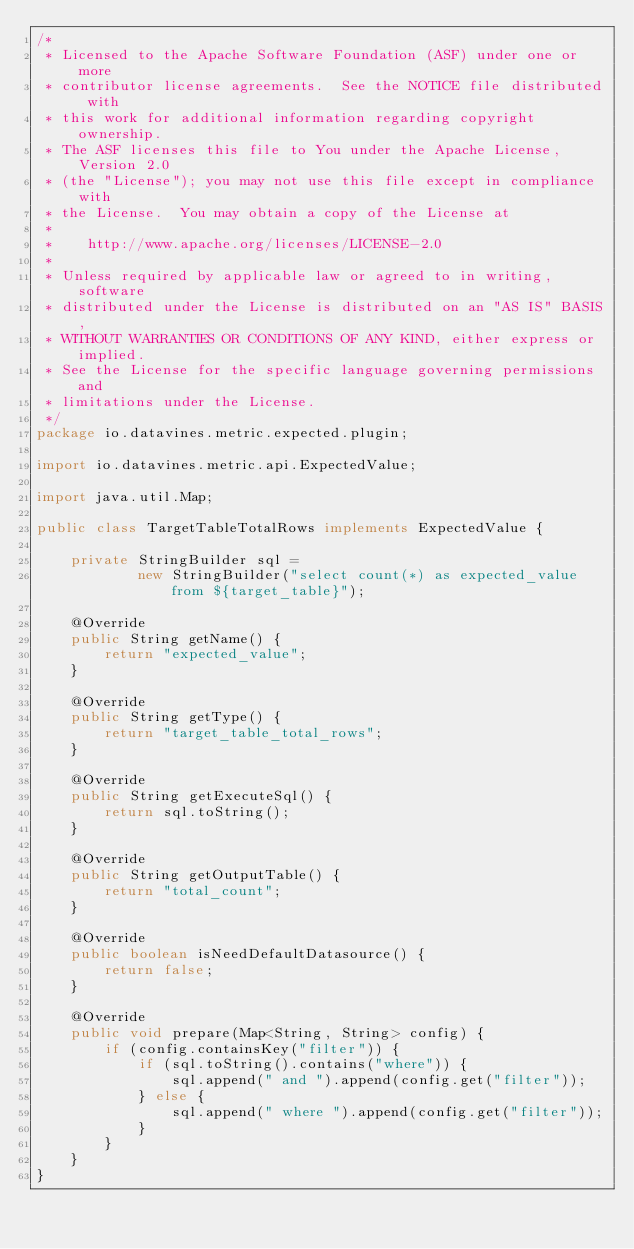Convert code to text. <code><loc_0><loc_0><loc_500><loc_500><_Java_>/*
 * Licensed to the Apache Software Foundation (ASF) under one or more
 * contributor license agreements.  See the NOTICE file distributed with
 * this work for additional information regarding copyright ownership.
 * The ASF licenses this file to You under the Apache License, Version 2.0
 * (the "License"); you may not use this file except in compliance with
 * the License.  You may obtain a copy of the License at
 *
 *    http://www.apache.org/licenses/LICENSE-2.0
 *
 * Unless required by applicable law or agreed to in writing, software
 * distributed under the License is distributed on an "AS IS" BASIS,
 * WITHOUT WARRANTIES OR CONDITIONS OF ANY KIND, either express or implied.
 * See the License for the specific language governing permissions and
 * limitations under the License.
 */
package io.datavines.metric.expected.plugin;

import io.datavines.metric.api.ExpectedValue;

import java.util.Map;

public class TargetTableTotalRows implements ExpectedValue {

    private StringBuilder sql =
            new StringBuilder("select count(*) as expected_value from ${target_table}");

    @Override
    public String getName() {
        return "expected_value";
    }

    @Override
    public String getType() {
        return "target_table_total_rows";
    }

    @Override
    public String getExecuteSql() {
        return sql.toString();
    }

    @Override
    public String getOutputTable() {
        return "total_count";
    }

    @Override
    public boolean isNeedDefaultDatasource() {
        return false;
    }

    @Override
    public void prepare(Map<String, String> config) {
        if (config.containsKey("filter")) {
            if (sql.toString().contains("where")) {
                sql.append(" and ").append(config.get("filter"));
            } else {
                sql.append(" where ").append(config.get("filter"));
            }
        }
    }
}
</code> 